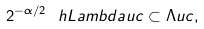Convert formula to latex. <formula><loc_0><loc_0><loc_500><loc_500>2 ^ { - \alpha / 2 } \ h L a m b d a u c \subset \Lambda u c ,</formula> 